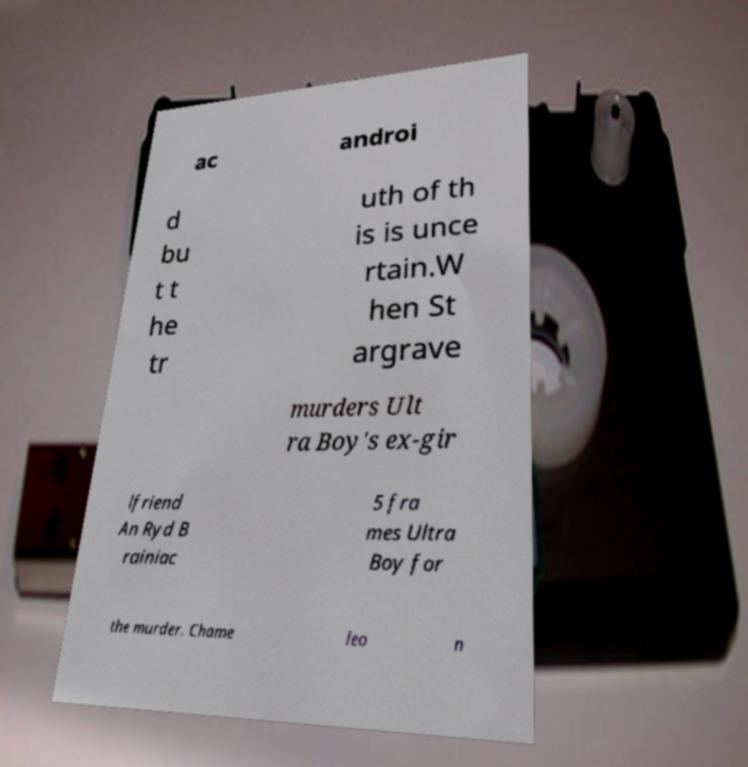Please read and relay the text visible in this image. What does it say? ac androi d bu t t he tr uth of th is is unce rtain.W hen St argrave murders Ult ra Boy's ex-gir lfriend An Ryd B rainiac 5 fra mes Ultra Boy for the murder. Chame leo n 